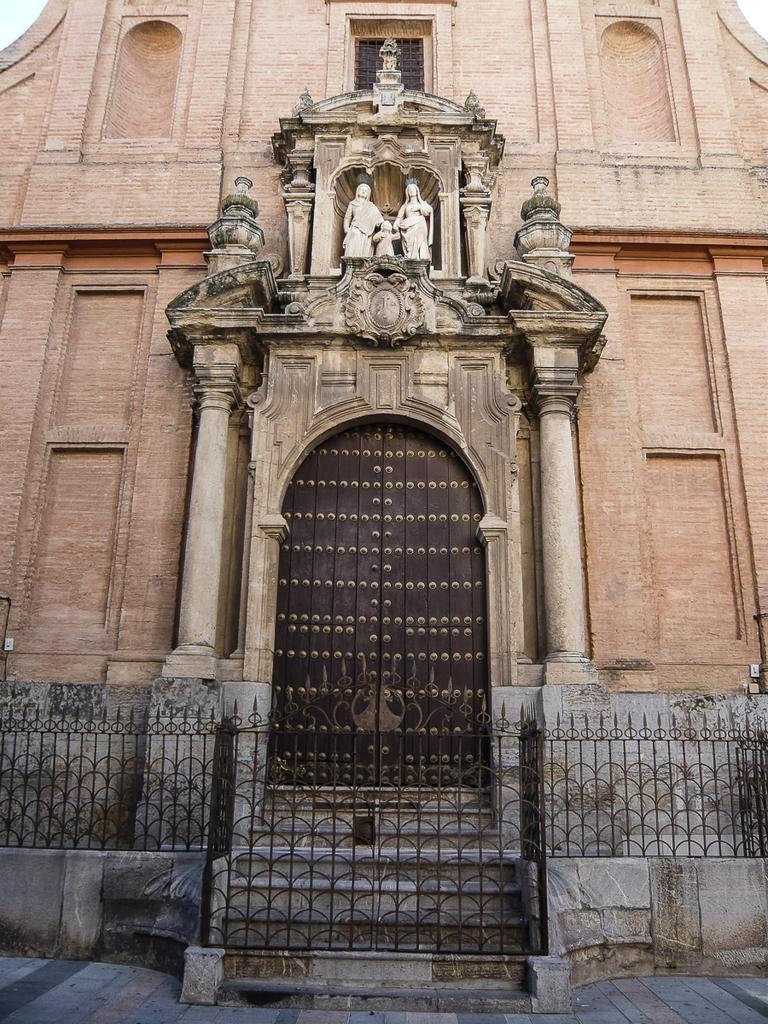Can you describe this image briefly? This image is taken outdoors. At the bottom of the image there is a floor. In the middle of the image there is a building with walls, pillars, a window and a door. There are a few carvings and sculptures on the walls. There is a railing. There are few stairs. 